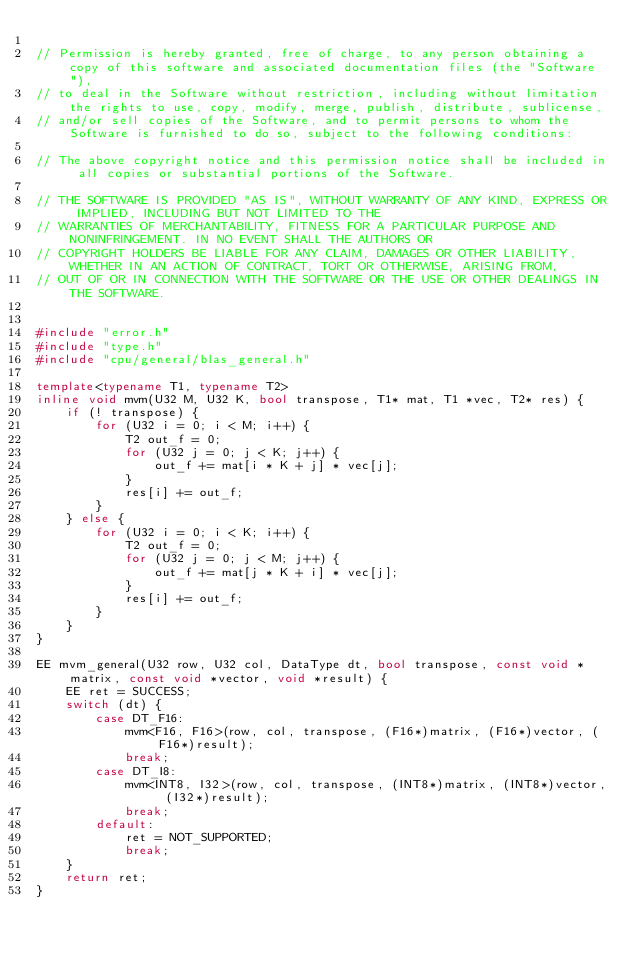Convert code to text. <code><loc_0><loc_0><loc_500><loc_500><_C++_>
// Permission is hereby granted, free of charge, to any person obtaining a copy of this software and associated documentation files (the "Software"), 
// to deal in the Software without restriction, including without limitation the rights to use, copy, modify, merge, publish, distribute, sublicense, 
// and/or sell copies of the Software, and to permit persons to whom the Software is furnished to do so, subject to the following conditions:

// The above copyright notice and this permission notice shall be included in all copies or substantial portions of the Software.

// THE SOFTWARE IS PROVIDED "AS IS", WITHOUT WARRANTY OF ANY KIND, EXPRESS OR IMPLIED, INCLUDING BUT NOT LIMITED TO THE 
// WARRANTIES OF MERCHANTABILITY, FITNESS FOR A PARTICULAR PURPOSE AND NONINFRINGEMENT. IN NO EVENT SHALL THE AUTHORS OR 
// COPYRIGHT HOLDERS BE LIABLE FOR ANY CLAIM, DAMAGES OR OTHER LIABILITY, WHETHER IN AN ACTION OF CONTRACT, TORT OR OTHERWISE, ARISING FROM, 
// OUT OF OR IN CONNECTION WITH THE SOFTWARE OR THE USE OR OTHER DEALINGS IN THE SOFTWARE.


#include "error.h"
#include "type.h"
#include "cpu/general/blas_general.h"

template<typename T1, typename T2>
inline void mvm(U32 M, U32 K, bool transpose, T1* mat, T1 *vec, T2* res) {
    if (! transpose) {
        for (U32 i = 0; i < M; i++) {
            T2 out_f = 0;
            for (U32 j = 0; j < K; j++) {
                out_f += mat[i * K + j] * vec[j];
            }
            res[i] += out_f;
        }
    } else {
        for (U32 i = 0; i < K; i++) {
            T2 out_f = 0;
            for (U32 j = 0; j < M; j++) {
                out_f += mat[j * K + i] * vec[j];
            }
            res[i] += out_f;
        }
    }
}

EE mvm_general(U32 row, U32 col, DataType dt, bool transpose, const void *matrix, const void *vector, void *result) {
    EE ret = SUCCESS;
    switch (dt) {
        case DT_F16:
            mvm<F16, F16>(row, col, transpose, (F16*)matrix, (F16*)vector, (F16*)result);
            break;
        case DT_I8:
            mvm<INT8, I32>(row, col, transpose, (INT8*)matrix, (INT8*)vector, (I32*)result);
            break;
        default:
            ret = NOT_SUPPORTED;
            break;
    }
    return ret;
}
</code> 